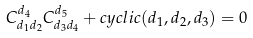Convert formula to latex. <formula><loc_0><loc_0><loc_500><loc_500>C _ { d _ { 1 } d _ { 2 } } ^ { d _ { 4 } } C _ { d _ { 3 } d _ { 4 } } ^ { d _ { 5 } } + c y c l i c ( d _ { 1 } , d _ { 2 } , d _ { 3 } ) = 0</formula> 